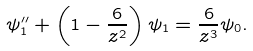<formula> <loc_0><loc_0><loc_500><loc_500>\psi _ { 1 } ^ { \prime \prime } + \left ( 1 - \frac { 6 } { z ^ { 2 } } \right ) \psi _ { 1 } = \frac { 6 } { z ^ { 3 } } \psi _ { 0 } .</formula> 